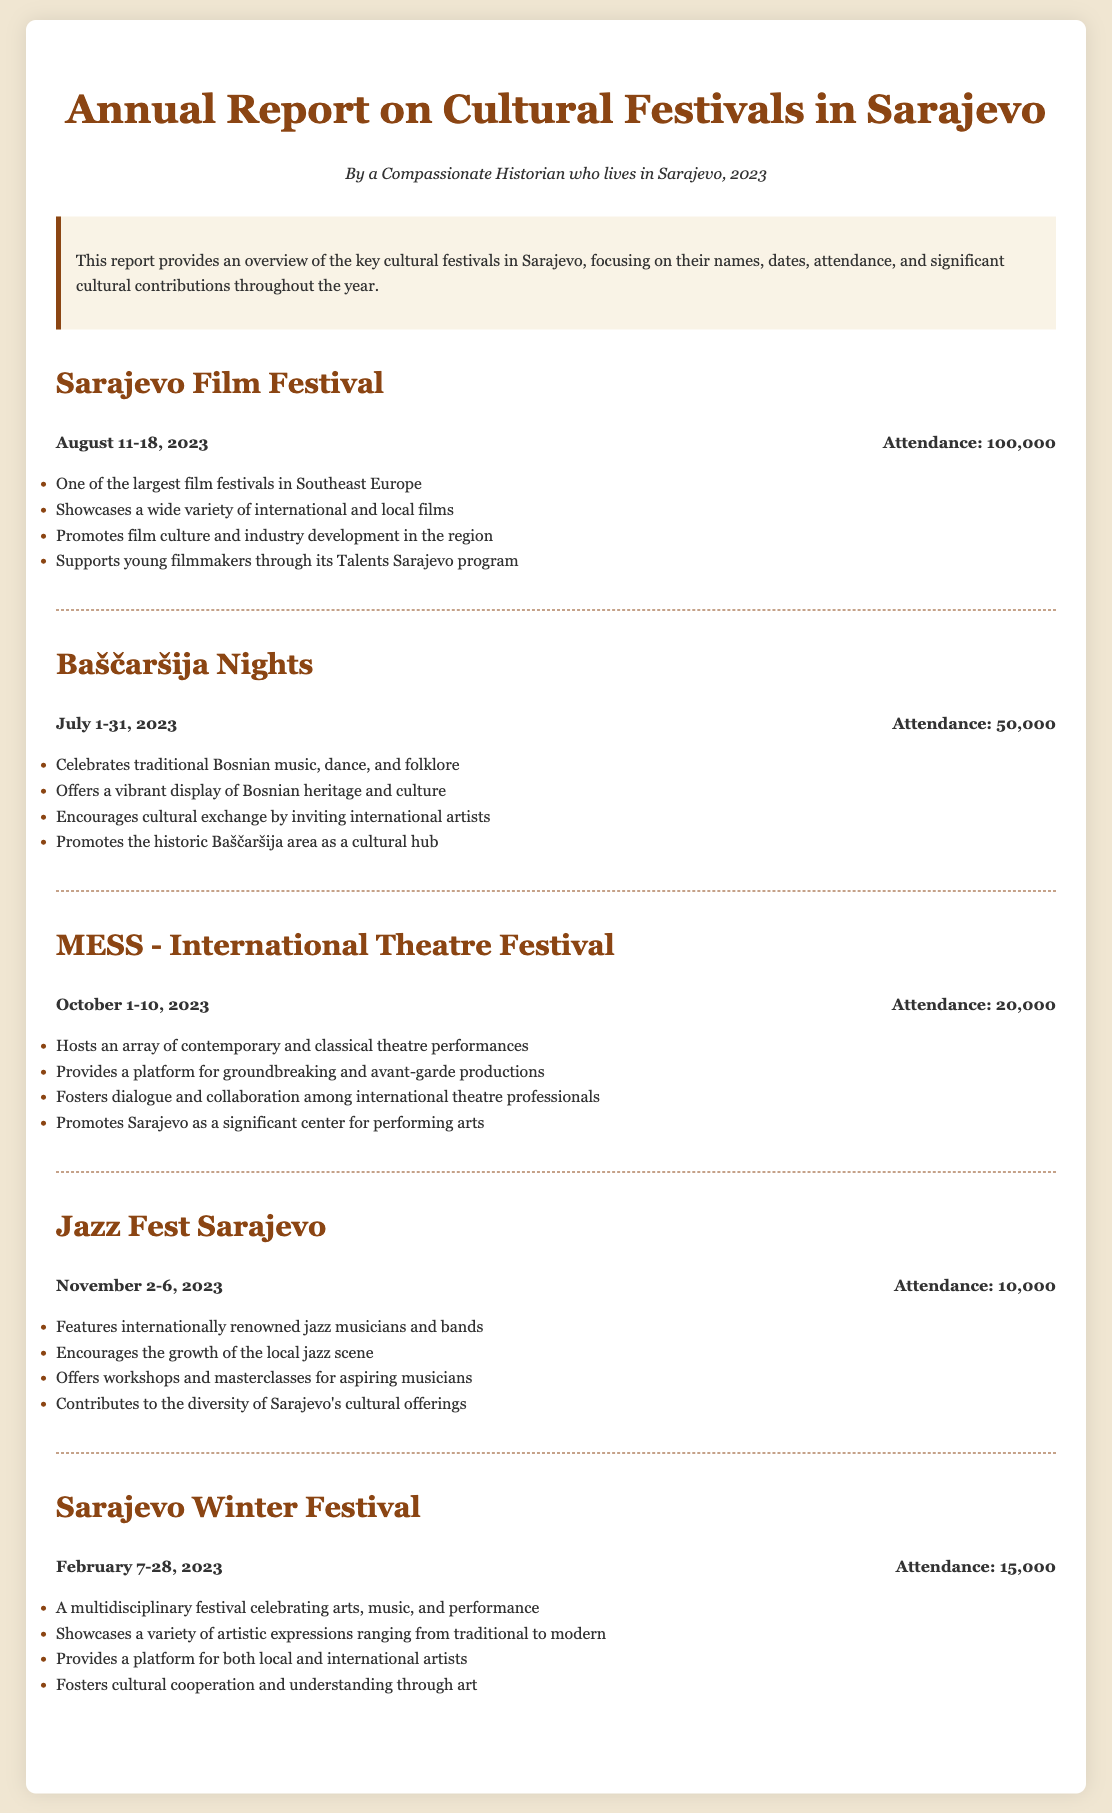what is the name of the largest film festival in Southeast Europe? The document identifies the Sarajevo Film Festival as one of the largest film festivals in Southeast Europe.
Answer: Sarajevo Film Festival when does the MESS - International Theatre Festival take place? The MESS - International Theatre Festival is scheduled from October 1 to October 10 in 2023.
Answer: October 1-10, 2023 how many people attended Baščaršija Nights? The attendance for Baščaršija Nights is reported to be 50,000 people.
Answer: 50,000 which festival celebrates traditional Bosnian music, dance, and folklore? The document specifies that Baščaršija Nights celebrates traditional Bosnian music, dance, and folklore.
Answer: Baščaršija Nights which month has the Sarajevo Winter Festival? The Sarajevo Winter Festival takes place in February.
Answer: February what is the attendance for Jazz Fest Sarajevo? The document states that the attendance for Jazz Fest Sarajevo is 10,000 people.
Answer: 10,000 which festival promotes young filmmakers through its program? The Sarajevo Film Festival promotes young filmmakers through its Talents Sarajevo program.
Answer: Sarajevo Film Festival what type of performances does MESS host? The MESS festival hosts contemporary and classical theatre performances.
Answer: Theatre performances how does the Jazz Fest Sarajevo contribute to local culture? The festival encourages the growth of the local jazz scene.
Answer: Growth of local jazz scene 